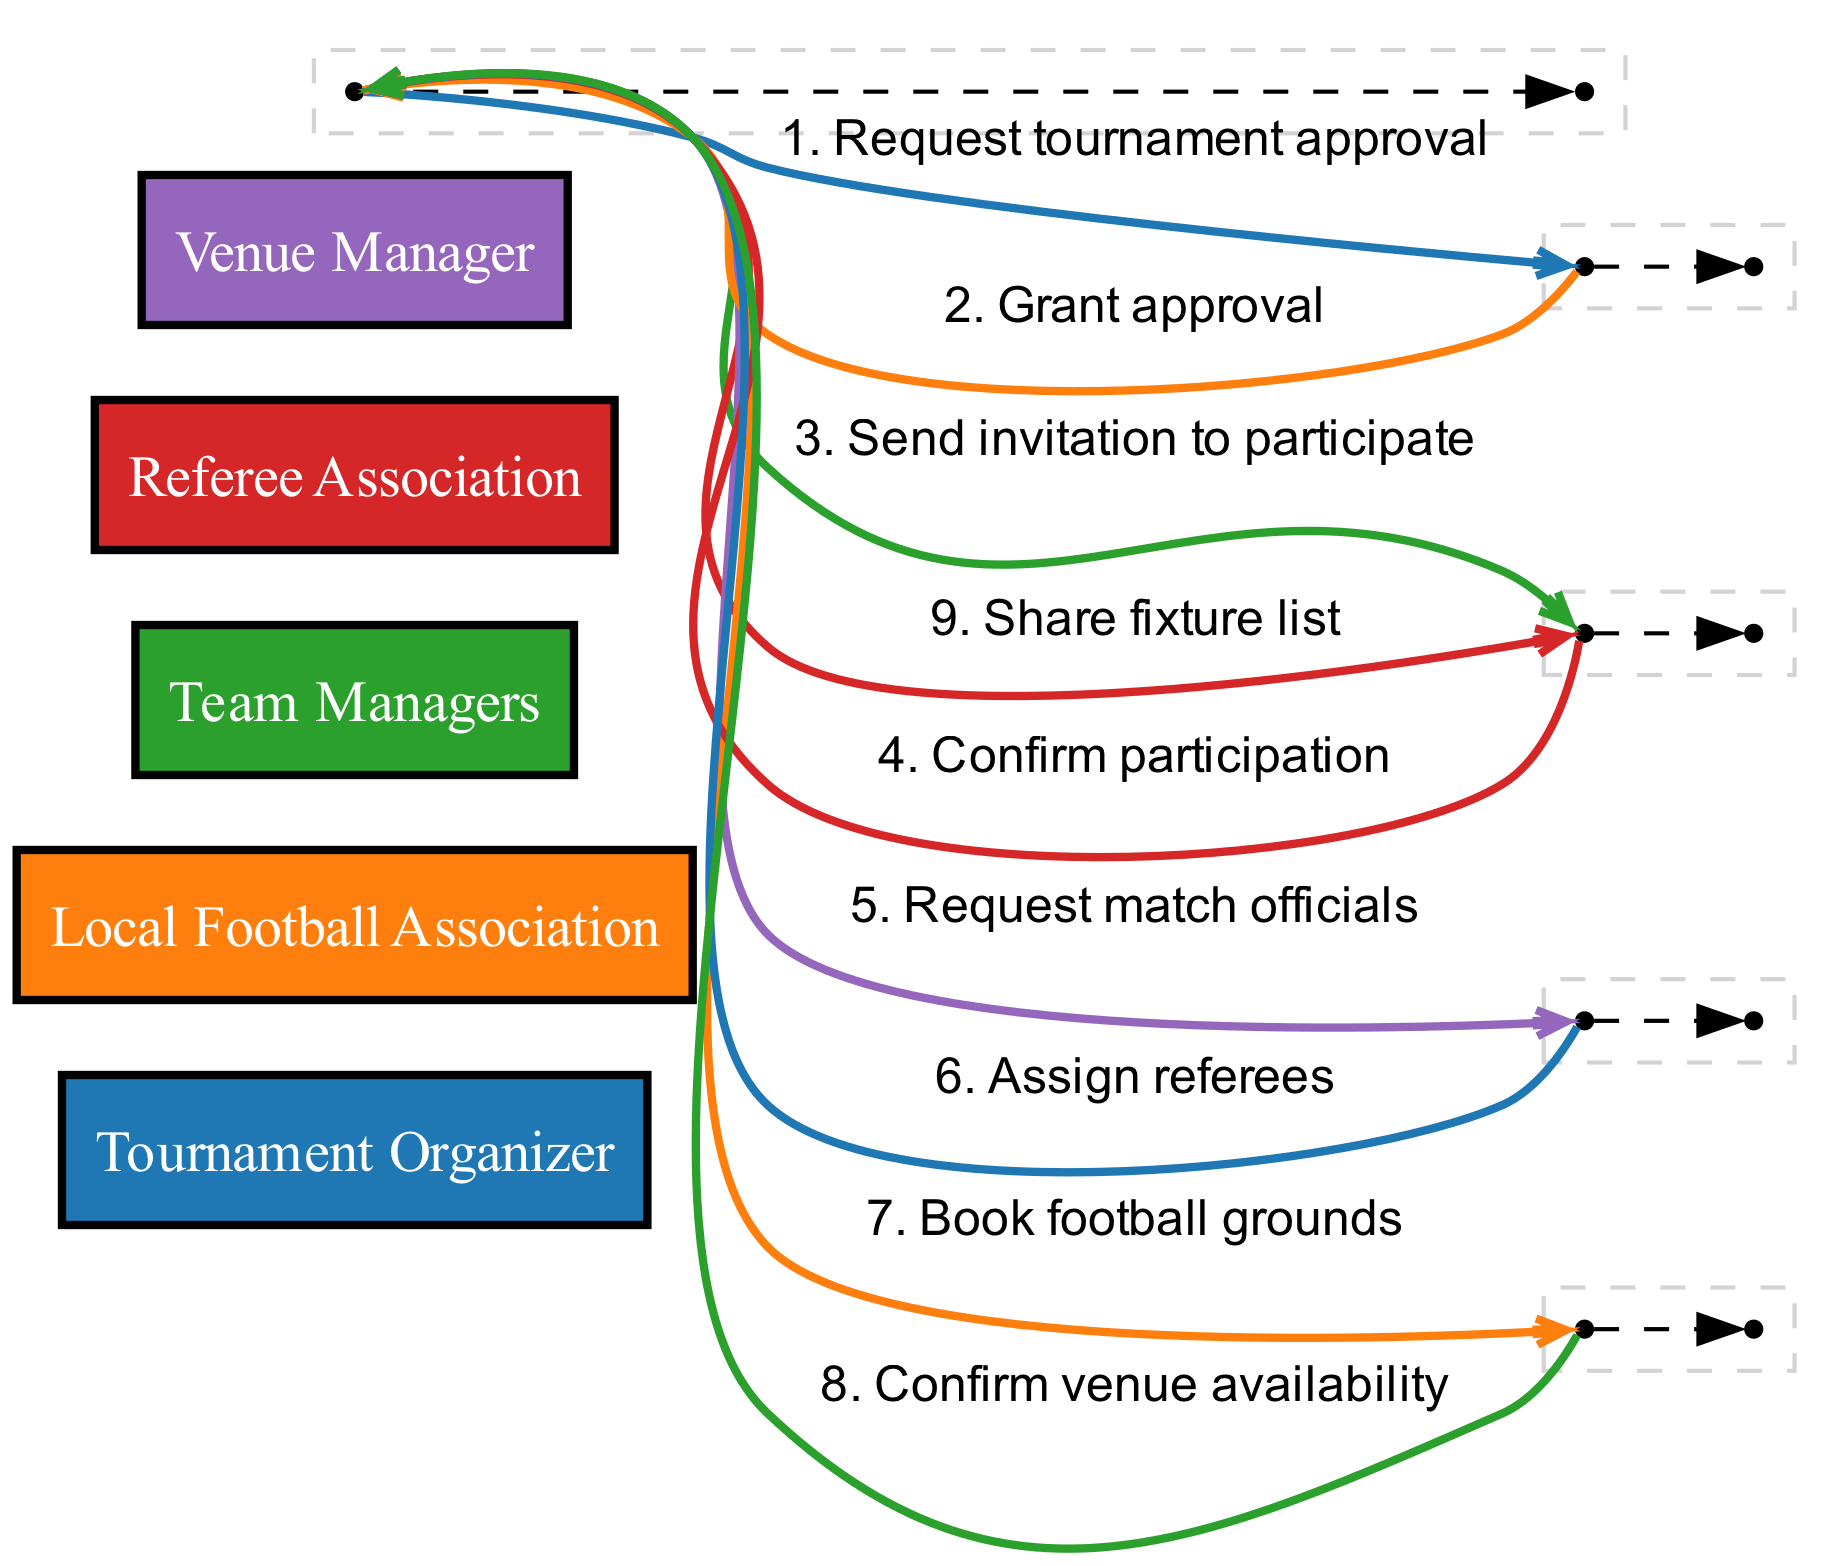What is the first action taken by the Tournament Organizer? The Tournament Organizer's first action is to request tournament approval from the Local Football Association. This is the first interaction in the sequence diagram and can be found at the beginning of the sequence representing the organizational steps.
Answer: Request tournament approval How many actors are involved in the sequence? The diagram lists five distinct actors represented: Tournament Organizer, Local Football Association, Team Managers, Referee Association, and Venue Manager. Therefore, the count of unique actors is five.
Answer: Five Which actor confirms the venue availability? The Venue Manager is the actor responsible for confirming the venue availability. This can be identified in the sequence where the Venue Manager responds to the Tournament Organizer.
Answer: Venue Manager What is the total number of messages exchanged in this sequence? There are a total of eight messages exchanged throughout the sequence diagram. This can be counted directly from the sequence steps listed, each representing a message.
Answer: Eight Which actor is responsible for assigning referees? The Referee Association is the actor that assigns referees. This is highlighted in the sequence where the Referee Association responds to a request from the Tournament Organizer.
Answer: Referee Association What action follows after team managers confirm participation? After the Team Managers confirm participation, the next action taken by the Tournament Organizer is to share the fixture list. This follows logically from the sequence of messages and actions.
Answer: Share fixture list Identify the actor that books the football grounds. The actor responsible for booking the football grounds is the Tournament Organizer. This is shown in the sequence diagram where the Tournament Organizer sends a booking request to the Venue Manager.
Answer: Tournament Organizer Which action comes after the Local Football Association grants approval? After the Local Football Association grants approval, the action taken by the Tournament Organizer is to send invitations to the Team Managers. This is the subsequent step reflected in the sequence.
Answer: Send invitation to participate 